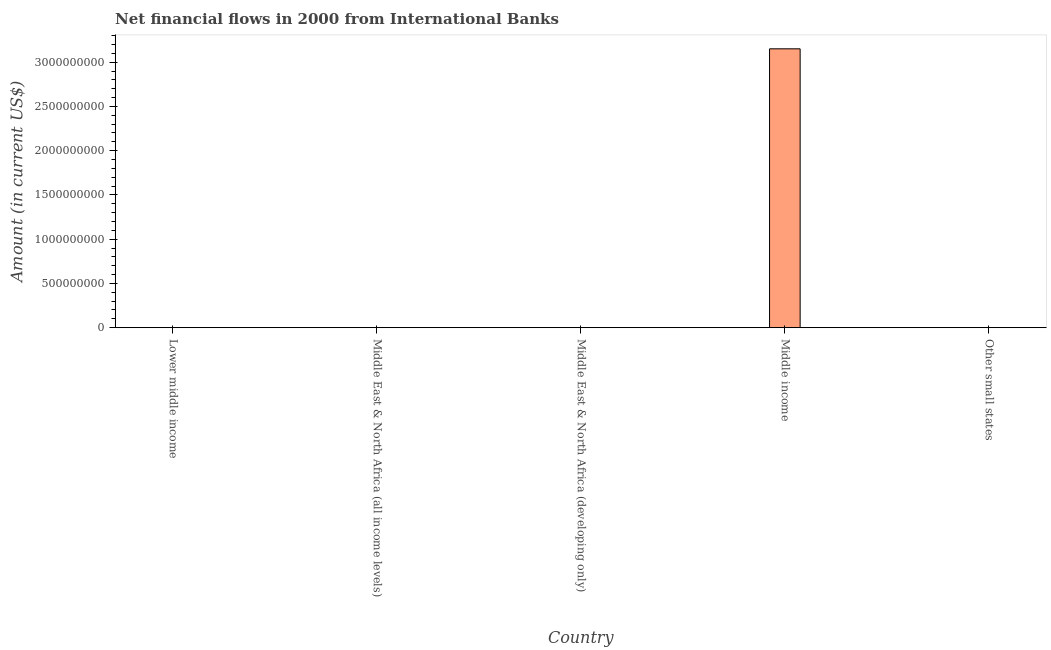What is the title of the graph?
Provide a short and direct response. Net financial flows in 2000 from International Banks. What is the label or title of the X-axis?
Give a very brief answer. Country. What is the label or title of the Y-axis?
Give a very brief answer. Amount (in current US$). Across all countries, what is the maximum net financial flows from ibrd?
Make the answer very short. 3.15e+09. Across all countries, what is the minimum net financial flows from ibrd?
Provide a short and direct response. 0. In which country was the net financial flows from ibrd maximum?
Offer a terse response. Middle income. What is the sum of the net financial flows from ibrd?
Your response must be concise. 3.15e+09. What is the average net financial flows from ibrd per country?
Offer a very short reply. 6.30e+08. What is the difference between the highest and the lowest net financial flows from ibrd?
Keep it short and to the point. 3.15e+09. In how many countries, is the net financial flows from ibrd greater than the average net financial flows from ibrd taken over all countries?
Keep it short and to the point. 1. How many bars are there?
Your response must be concise. 1. Are all the bars in the graph horizontal?
Provide a short and direct response. No. How many countries are there in the graph?
Give a very brief answer. 5. Are the values on the major ticks of Y-axis written in scientific E-notation?
Ensure brevity in your answer.  No. What is the Amount (in current US$) of Lower middle income?
Provide a short and direct response. 0. What is the Amount (in current US$) in Middle East & North Africa (all income levels)?
Keep it short and to the point. 0. What is the Amount (in current US$) in Middle income?
Provide a short and direct response. 3.15e+09. 